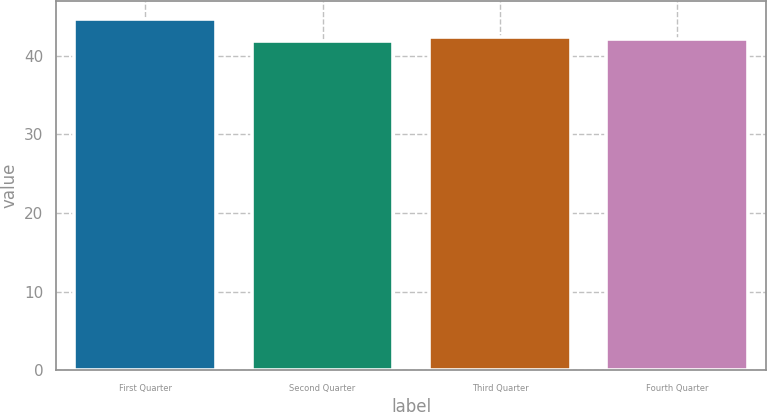<chart> <loc_0><loc_0><loc_500><loc_500><bar_chart><fcel>First Quarter<fcel>Second Quarter<fcel>Third Quarter<fcel>Fourth Quarter<nl><fcel>44.7<fcel>41.85<fcel>42.42<fcel>42.14<nl></chart> 